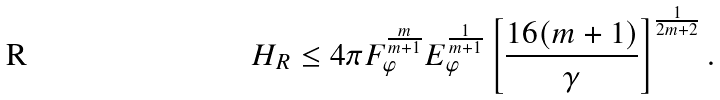<formula> <loc_0><loc_0><loc_500><loc_500>H _ { R } \leq 4 \pi F _ { \varphi } ^ { \frac { m } { m + 1 } } E _ { \varphi } ^ { \frac { 1 } { m + 1 } } \left [ \frac { 1 6 ( m + 1 ) } { \gamma } \right ] ^ { \frac { 1 } { 2 m + 2 } } .</formula> 